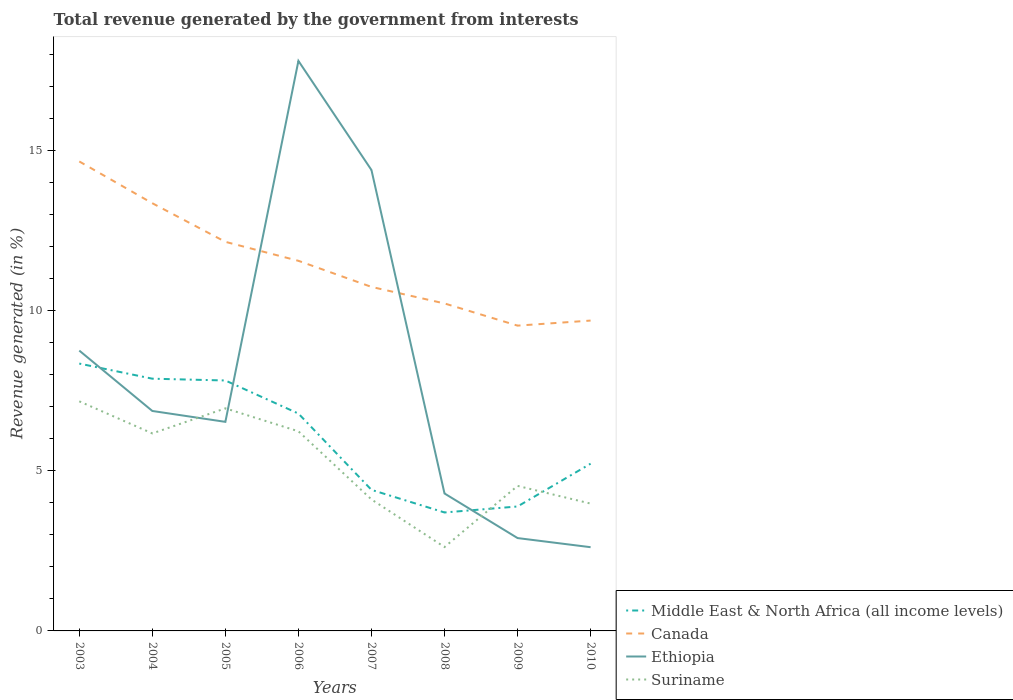Does the line corresponding to Suriname intersect with the line corresponding to Ethiopia?
Offer a terse response. Yes. Is the number of lines equal to the number of legend labels?
Keep it short and to the point. Yes. Across all years, what is the maximum total revenue generated in Canada?
Make the answer very short. 9.53. What is the total total revenue generated in Ethiopia in the graph?
Keep it short and to the point. 2.58. What is the difference between the highest and the second highest total revenue generated in Canada?
Your response must be concise. 5.12. Is the total revenue generated in Canada strictly greater than the total revenue generated in Middle East & North Africa (all income levels) over the years?
Your answer should be very brief. No. Does the graph contain any zero values?
Provide a short and direct response. No. Does the graph contain grids?
Your response must be concise. No. How are the legend labels stacked?
Your answer should be very brief. Vertical. What is the title of the graph?
Your response must be concise. Total revenue generated by the government from interests. Does "High income" appear as one of the legend labels in the graph?
Provide a short and direct response. No. What is the label or title of the Y-axis?
Your answer should be compact. Revenue generated (in %). What is the Revenue generated (in %) in Middle East & North Africa (all income levels) in 2003?
Your response must be concise. 8.34. What is the Revenue generated (in %) in Canada in 2003?
Your response must be concise. 14.65. What is the Revenue generated (in %) of Ethiopia in 2003?
Make the answer very short. 8.75. What is the Revenue generated (in %) of Suriname in 2003?
Offer a very short reply. 7.17. What is the Revenue generated (in %) in Middle East & North Africa (all income levels) in 2004?
Ensure brevity in your answer.  7.87. What is the Revenue generated (in %) of Canada in 2004?
Offer a very short reply. 13.35. What is the Revenue generated (in %) in Ethiopia in 2004?
Offer a very short reply. 6.86. What is the Revenue generated (in %) of Suriname in 2004?
Give a very brief answer. 6.16. What is the Revenue generated (in %) in Middle East & North Africa (all income levels) in 2005?
Your answer should be compact. 7.82. What is the Revenue generated (in %) in Canada in 2005?
Offer a terse response. 12.14. What is the Revenue generated (in %) of Ethiopia in 2005?
Your answer should be compact. 6.52. What is the Revenue generated (in %) in Suriname in 2005?
Provide a succinct answer. 6.95. What is the Revenue generated (in %) of Middle East & North Africa (all income levels) in 2006?
Provide a succinct answer. 6.78. What is the Revenue generated (in %) in Canada in 2006?
Give a very brief answer. 11.55. What is the Revenue generated (in %) in Ethiopia in 2006?
Offer a terse response. 17.79. What is the Revenue generated (in %) of Suriname in 2006?
Provide a succinct answer. 6.23. What is the Revenue generated (in %) in Middle East & North Africa (all income levels) in 2007?
Provide a short and direct response. 4.4. What is the Revenue generated (in %) of Canada in 2007?
Give a very brief answer. 10.74. What is the Revenue generated (in %) of Ethiopia in 2007?
Provide a succinct answer. 14.38. What is the Revenue generated (in %) in Suriname in 2007?
Provide a succinct answer. 4.1. What is the Revenue generated (in %) of Middle East & North Africa (all income levels) in 2008?
Your answer should be compact. 3.7. What is the Revenue generated (in %) of Canada in 2008?
Your answer should be compact. 10.22. What is the Revenue generated (in %) of Ethiopia in 2008?
Ensure brevity in your answer.  4.29. What is the Revenue generated (in %) of Suriname in 2008?
Ensure brevity in your answer.  2.62. What is the Revenue generated (in %) in Middle East & North Africa (all income levels) in 2009?
Provide a short and direct response. 3.88. What is the Revenue generated (in %) in Canada in 2009?
Your answer should be very brief. 9.53. What is the Revenue generated (in %) in Ethiopia in 2009?
Give a very brief answer. 2.9. What is the Revenue generated (in %) in Suriname in 2009?
Your answer should be very brief. 4.53. What is the Revenue generated (in %) of Middle East & North Africa (all income levels) in 2010?
Your response must be concise. 5.22. What is the Revenue generated (in %) of Canada in 2010?
Make the answer very short. 9.69. What is the Revenue generated (in %) in Ethiopia in 2010?
Ensure brevity in your answer.  2.61. What is the Revenue generated (in %) of Suriname in 2010?
Offer a very short reply. 3.97. Across all years, what is the maximum Revenue generated (in %) in Middle East & North Africa (all income levels)?
Ensure brevity in your answer.  8.34. Across all years, what is the maximum Revenue generated (in %) of Canada?
Ensure brevity in your answer.  14.65. Across all years, what is the maximum Revenue generated (in %) in Ethiopia?
Your answer should be compact. 17.79. Across all years, what is the maximum Revenue generated (in %) of Suriname?
Ensure brevity in your answer.  7.17. Across all years, what is the minimum Revenue generated (in %) in Middle East & North Africa (all income levels)?
Ensure brevity in your answer.  3.7. Across all years, what is the minimum Revenue generated (in %) of Canada?
Your answer should be compact. 9.53. Across all years, what is the minimum Revenue generated (in %) in Ethiopia?
Your response must be concise. 2.61. Across all years, what is the minimum Revenue generated (in %) of Suriname?
Keep it short and to the point. 2.62. What is the total Revenue generated (in %) of Middle East & North Africa (all income levels) in the graph?
Offer a terse response. 48.02. What is the total Revenue generated (in %) of Canada in the graph?
Offer a terse response. 91.87. What is the total Revenue generated (in %) in Ethiopia in the graph?
Keep it short and to the point. 64.11. What is the total Revenue generated (in %) of Suriname in the graph?
Keep it short and to the point. 41.73. What is the difference between the Revenue generated (in %) in Middle East & North Africa (all income levels) in 2003 and that in 2004?
Make the answer very short. 0.47. What is the difference between the Revenue generated (in %) in Canada in 2003 and that in 2004?
Provide a short and direct response. 1.3. What is the difference between the Revenue generated (in %) in Ethiopia in 2003 and that in 2004?
Keep it short and to the point. 1.88. What is the difference between the Revenue generated (in %) of Suriname in 2003 and that in 2004?
Offer a terse response. 1. What is the difference between the Revenue generated (in %) of Middle East & North Africa (all income levels) in 2003 and that in 2005?
Offer a very short reply. 0.53. What is the difference between the Revenue generated (in %) of Canada in 2003 and that in 2005?
Keep it short and to the point. 2.51. What is the difference between the Revenue generated (in %) of Ethiopia in 2003 and that in 2005?
Provide a succinct answer. 2.22. What is the difference between the Revenue generated (in %) of Suriname in 2003 and that in 2005?
Your answer should be very brief. 0.22. What is the difference between the Revenue generated (in %) in Middle East & North Africa (all income levels) in 2003 and that in 2006?
Offer a very short reply. 1.56. What is the difference between the Revenue generated (in %) in Canada in 2003 and that in 2006?
Your response must be concise. 3.1. What is the difference between the Revenue generated (in %) of Ethiopia in 2003 and that in 2006?
Ensure brevity in your answer.  -9.04. What is the difference between the Revenue generated (in %) of Suriname in 2003 and that in 2006?
Your answer should be very brief. 0.94. What is the difference between the Revenue generated (in %) in Middle East & North Africa (all income levels) in 2003 and that in 2007?
Keep it short and to the point. 3.94. What is the difference between the Revenue generated (in %) in Canada in 2003 and that in 2007?
Ensure brevity in your answer.  3.92. What is the difference between the Revenue generated (in %) of Ethiopia in 2003 and that in 2007?
Provide a succinct answer. -5.63. What is the difference between the Revenue generated (in %) of Suriname in 2003 and that in 2007?
Keep it short and to the point. 3.06. What is the difference between the Revenue generated (in %) of Middle East & North Africa (all income levels) in 2003 and that in 2008?
Your answer should be very brief. 4.65. What is the difference between the Revenue generated (in %) in Canada in 2003 and that in 2008?
Provide a succinct answer. 4.43. What is the difference between the Revenue generated (in %) in Ethiopia in 2003 and that in 2008?
Your response must be concise. 4.46. What is the difference between the Revenue generated (in %) in Suriname in 2003 and that in 2008?
Your answer should be compact. 4.55. What is the difference between the Revenue generated (in %) in Middle East & North Africa (all income levels) in 2003 and that in 2009?
Offer a terse response. 4.46. What is the difference between the Revenue generated (in %) in Canada in 2003 and that in 2009?
Offer a terse response. 5.12. What is the difference between the Revenue generated (in %) in Ethiopia in 2003 and that in 2009?
Offer a terse response. 5.85. What is the difference between the Revenue generated (in %) of Suriname in 2003 and that in 2009?
Offer a terse response. 2.64. What is the difference between the Revenue generated (in %) in Middle East & North Africa (all income levels) in 2003 and that in 2010?
Ensure brevity in your answer.  3.12. What is the difference between the Revenue generated (in %) of Canada in 2003 and that in 2010?
Make the answer very short. 4.97. What is the difference between the Revenue generated (in %) in Ethiopia in 2003 and that in 2010?
Your answer should be compact. 6.14. What is the difference between the Revenue generated (in %) in Suriname in 2003 and that in 2010?
Give a very brief answer. 3.19. What is the difference between the Revenue generated (in %) in Middle East & North Africa (all income levels) in 2004 and that in 2005?
Offer a terse response. 0.06. What is the difference between the Revenue generated (in %) in Canada in 2004 and that in 2005?
Your response must be concise. 1.21. What is the difference between the Revenue generated (in %) of Ethiopia in 2004 and that in 2005?
Keep it short and to the point. 0.34. What is the difference between the Revenue generated (in %) of Suriname in 2004 and that in 2005?
Your answer should be very brief. -0.78. What is the difference between the Revenue generated (in %) of Middle East & North Africa (all income levels) in 2004 and that in 2006?
Your answer should be very brief. 1.09. What is the difference between the Revenue generated (in %) of Canada in 2004 and that in 2006?
Ensure brevity in your answer.  1.8. What is the difference between the Revenue generated (in %) of Ethiopia in 2004 and that in 2006?
Provide a succinct answer. -10.93. What is the difference between the Revenue generated (in %) in Suriname in 2004 and that in 2006?
Provide a succinct answer. -0.07. What is the difference between the Revenue generated (in %) of Middle East & North Africa (all income levels) in 2004 and that in 2007?
Provide a short and direct response. 3.47. What is the difference between the Revenue generated (in %) in Canada in 2004 and that in 2007?
Keep it short and to the point. 2.61. What is the difference between the Revenue generated (in %) of Ethiopia in 2004 and that in 2007?
Keep it short and to the point. -7.52. What is the difference between the Revenue generated (in %) in Suriname in 2004 and that in 2007?
Provide a succinct answer. 2.06. What is the difference between the Revenue generated (in %) in Middle East & North Africa (all income levels) in 2004 and that in 2008?
Ensure brevity in your answer.  4.18. What is the difference between the Revenue generated (in %) in Canada in 2004 and that in 2008?
Make the answer very short. 3.13. What is the difference between the Revenue generated (in %) of Ethiopia in 2004 and that in 2008?
Your answer should be very brief. 2.58. What is the difference between the Revenue generated (in %) of Suriname in 2004 and that in 2008?
Offer a very short reply. 3.55. What is the difference between the Revenue generated (in %) in Middle East & North Africa (all income levels) in 2004 and that in 2009?
Provide a short and direct response. 3.99. What is the difference between the Revenue generated (in %) in Canada in 2004 and that in 2009?
Keep it short and to the point. 3.82. What is the difference between the Revenue generated (in %) in Ethiopia in 2004 and that in 2009?
Give a very brief answer. 3.97. What is the difference between the Revenue generated (in %) in Suriname in 2004 and that in 2009?
Provide a short and direct response. 1.64. What is the difference between the Revenue generated (in %) in Middle East & North Africa (all income levels) in 2004 and that in 2010?
Ensure brevity in your answer.  2.65. What is the difference between the Revenue generated (in %) of Canada in 2004 and that in 2010?
Make the answer very short. 3.66. What is the difference between the Revenue generated (in %) of Ethiopia in 2004 and that in 2010?
Make the answer very short. 4.25. What is the difference between the Revenue generated (in %) of Suriname in 2004 and that in 2010?
Your response must be concise. 2.19. What is the difference between the Revenue generated (in %) in Middle East & North Africa (all income levels) in 2005 and that in 2006?
Your response must be concise. 1.03. What is the difference between the Revenue generated (in %) in Canada in 2005 and that in 2006?
Provide a short and direct response. 0.59. What is the difference between the Revenue generated (in %) in Ethiopia in 2005 and that in 2006?
Make the answer very short. -11.27. What is the difference between the Revenue generated (in %) of Suriname in 2005 and that in 2006?
Give a very brief answer. 0.72. What is the difference between the Revenue generated (in %) in Middle East & North Africa (all income levels) in 2005 and that in 2007?
Provide a short and direct response. 3.41. What is the difference between the Revenue generated (in %) of Canada in 2005 and that in 2007?
Provide a short and direct response. 1.41. What is the difference between the Revenue generated (in %) of Ethiopia in 2005 and that in 2007?
Your response must be concise. -7.86. What is the difference between the Revenue generated (in %) of Suriname in 2005 and that in 2007?
Your answer should be compact. 2.84. What is the difference between the Revenue generated (in %) in Middle East & North Africa (all income levels) in 2005 and that in 2008?
Your answer should be very brief. 4.12. What is the difference between the Revenue generated (in %) in Canada in 2005 and that in 2008?
Offer a very short reply. 1.92. What is the difference between the Revenue generated (in %) in Ethiopia in 2005 and that in 2008?
Ensure brevity in your answer.  2.24. What is the difference between the Revenue generated (in %) of Suriname in 2005 and that in 2008?
Keep it short and to the point. 4.33. What is the difference between the Revenue generated (in %) in Middle East & North Africa (all income levels) in 2005 and that in 2009?
Your answer should be compact. 3.93. What is the difference between the Revenue generated (in %) of Canada in 2005 and that in 2009?
Your answer should be very brief. 2.62. What is the difference between the Revenue generated (in %) in Ethiopia in 2005 and that in 2009?
Offer a terse response. 3.63. What is the difference between the Revenue generated (in %) in Suriname in 2005 and that in 2009?
Your answer should be compact. 2.42. What is the difference between the Revenue generated (in %) of Middle East & North Africa (all income levels) in 2005 and that in 2010?
Your answer should be very brief. 2.6. What is the difference between the Revenue generated (in %) of Canada in 2005 and that in 2010?
Offer a terse response. 2.46. What is the difference between the Revenue generated (in %) in Ethiopia in 2005 and that in 2010?
Offer a terse response. 3.91. What is the difference between the Revenue generated (in %) in Suriname in 2005 and that in 2010?
Make the answer very short. 2.97. What is the difference between the Revenue generated (in %) of Middle East & North Africa (all income levels) in 2006 and that in 2007?
Make the answer very short. 2.38. What is the difference between the Revenue generated (in %) in Canada in 2006 and that in 2007?
Offer a terse response. 0.81. What is the difference between the Revenue generated (in %) of Ethiopia in 2006 and that in 2007?
Ensure brevity in your answer.  3.41. What is the difference between the Revenue generated (in %) of Suriname in 2006 and that in 2007?
Offer a very short reply. 2.13. What is the difference between the Revenue generated (in %) of Middle East & North Africa (all income levels) in 2006 and that in 2008?
Your response must be concise. 3.09. What is the difference between the Revenue generated (in %) in Canada in 2006 and that in 2008?
Make the answer very short. 1.33. What is the difference between the Revenue generated (in %) in Ethiopia in 2006 and that in 2008?
Keep it short and to the point. 13.5. What is the difference between the Revenue generated (in %) of Suriname in 2006 and that in 2008?
Make the answer very short. 3.61. What is the difference between the Revenue generated (in %) of Middle East & North Africa (all income levels) in 2006 and that in 2009?
Provide a short and direct response. 2.9. What is the difference between the Revenue generated (in %) of Canada in 2006 and that in 2009?
Make the answer very short. 2.02. What is the difference between the Revenue generated (in %) of Ethiopia in 2006 and that in 2009?
Make the answer very short. 14.89. What is the difference between the Revenue generated (in %) of Suriname in 2006 and that in 2009?
Make the answer very short. 1.7. What is the difference between the Revenue generated (in %) of Middle East & North Africa (all income levels) in 2006 and that in 2010?
Provide a succinct answer. 1.56. What is the difference between the Revenue generated (in %) of Canada in 2006 and that in 2010?
Offer a terse response. 1.87. What is the difference between the Revenue generated (in %) of Ethiopia in 2006 and that in 2010?
Give a very brief answer. 15.18. What is the difference between the Revenue generated (in %) of Suriname in 2006 and that in 2010?
Your response must be concise. 2.26. What is the difference between the Revenue generated (in %) in Middle East & North Africa (all income levels) in 2007 and that in 2008?
Provide a short and direct response. 0.71. What is the difference between the Revenue generated (in %) of Canada in 2007 and that in 2008?
Keep it short and to the point. 0.52. What is the difference between the Revenue generated (in %) in Ethiopia in 2007 and that in 2008?
Offer a very short reply. 10.09. What is the difference between the Revenue generated (in %) of Suriname in 2007 and that in 2008?
Provide a succinct answer. 1.49. What is the difference between the Revenue generated (in %) in Middle East & North Africa (all income levels) in 2007 and that in 2009?
Keep it short and to the point. 0.52. What is the difference between the Revenue generated (in %) of Canada in 2007 and that in 2009?
Provide a short and direct response. 1.21. What is the difference between the Revenue generated (in %) of Ethiopia in 2007 and that in 2009?
Offer a very short reply. 11.49. What is the difference between the Revenue generated (in %) of Suriname in 2007 and that in 2009?
Your response must be concise. -0.42. What is the difference between the Revenue generated (in %) of Middle East & North Africa (all income levels) in 2007 and that in 2010?
Give a very brief answer. -0.82. What is the difference between the Revenue generated (in %) in Canada in 2007 and that in 2010?
Make the answer very short. 1.05. What is the difference between the Revenue generated (in %) of Ethiopia in 2007 and that in 2010?
Ensure brevity in your answer.  11.77. What is the difference between the Revenue generated (in %) of Suriname in 2007 and that in 2010?
Offer a very short reply. 0.13. What is the difference between the Revenue generated (in %) of Middle East & North Africa (all income levels) in 2008 and that in 2009?
Ensure brevity in your answer.  -0.19. What is the difference between the Revenue generated (in %) of Canada in 2008 and that in 2009?
Your answer should be compact. 0.69. What is the difference between the Revenue generated (in %) of Ethiopia in 2008 and that in 2009?
Your answer should be compact. 1.39. What is the difference between the Revenue generated (in %) of Suriname in 2008 and that in 2009?
Provide a short and direct response. -1.91. What is the difference between the Revenue generated (in %) in Middle East & North Africa (all income levels) in 2008 and that in 2010?
Keep it short and to the point. -1.52. What is the difference between the Revenue generated (in %) in Canada in 2008 and that in 2010?
Make the answer very short. 0.53. What is the difference between the Revenue generated (in %) of Ethiopia in 2008 and that in 2010?
Your answer should be very brief. 1.68. What is the difference between the Revenue generated (in %) in Suriname in 2008 and that in 2010?
Keep it short and to the point. -1.36. What is the difference between the Revenue generated (in %) of Middle East & North Africa (all income levels) in 2009 and that in 2010?
Provide a short and direct response. -1.34. What is the difference between the Revenue generated (in %) in Canada in 2009 and that in 2010?
Provide a short and direct response. -0.16. What is the difference between the Revenue generated (in %) in Ethiopia in 2009 and that in 2010?
Offer a terse response. 0.29. What is the difference between the Revenue generated (in %) in Suriname in 2009 and that in 2010?
Make the answer very short. 0.55. What is the difference between the Revenue generated (in %) in Middle East & North Africa (all income levels) in 2003 and the Revenue generated (in %) in Canada in 2004?
Provide a succinct answer. -5. What is the difference between the Revenue generated (in %) of Middle East & North Africa (all income levels) in 2003 and the Revenue generated (in %) of Ethiopia in 2004?
Ensure brevity in your answer.  1.48. What is the difference between the Revenue generated (in %) in Middle East & North Africa (all income levels) in 2003 and the Revenue generated (in %) in Suriname in 2004?
Make the answer very short. 2.18. What is the difference between the Revenue generated (in %) in Canada in 2003 and the Revenue generated (in %) in Ethiopia in 2004?
Your answer should be very brief. 7.79. What is the difference between the Revenue generated (in %) of Canada in 2003 and the Revenue generated (in %) of Suriname in 2004?
Provide a succinct answer. 8.49. What is the difference between the Revenue generated (in %) in Ethiopia in 2003 and the Revenue generated (in %) in Suriname in 2004?
Provide a succinct answer. 2.59. What is the difference between the Revenue generated (in %) of Middle East & North Africa (all income levels) in 2003 and the Revenue generated (in %) of Canada in 2005?
Ensure brevity in your answer.  -3.8. What is the difference between the Revenue generated (in %) in Middle East & North Africa (all income levels) in 2003 and the Revenue generated (in %) in Ethiopia in 2005?
Provide a succinct answer. 1.82. What is the difference between the Revenue generated (in %) in Middle East & North Africa (all income levels) in 2003 and the Revenue generated (in %) in Suriname in 2005?
Your response must be concise. 1.4. What is the difference between the Revenue generated (in %) in Canada in 2003 and the Revenue generated (in %) in Ethiopia in 2005?
Give a very brief answer. 8.13. What is the difference between the Revenue generated (in %) in Canada in 2003 and the Revenue generated (in %) in Suriname in 2005?
Ensure brevity in your answer.  7.71. What is the difference between the Revenue generated (in %) in Ethiopia in 2003 and the Revenue generated (in %) in Suriname in 2005?
Ensure brevity in your answer.  1.8. What is the difference between the Revenue generated (in %) in Middle East & North Africa (all income levels) in 2003 and the Revenue generated (in %) in Canada in 2006?
Offer a very short reply. -3.21. What is the difference between the Revenue generated (in %) in Middle East & North Africa (all income levels) in 2003 and the Revenue generated (in %) in Ethiopia in 2006?
Your answer should be very brief. -9.45. What is the difference between the Revenue generated (in %) of Middle East & North Africa (all income levels) in 2003 and the Revenue generated (in %) of Suriname in 2006?
Keep it short and to the point. 2.11. What is the difference between the Revenue generated (in %) in Canada in 2003 and the Revenue generated (in %) in Ethiopia in 2006?
Ensure brevity in your answer.  -3.14. What is the difference between the Revenue generated (in %) of Canada in 2003 and the Revenue generated (in %) of Suriname in 2006?
Give a very brief answer. 8.42. What is the difference between the Revenue generated (in %) in Ethiopia in 2003 and the Revenue generated (in %) in Suriname in 2006?
Give a very brief answer. 2.52. What is the difference between the Revenue generated (in %) in Middle East & North Africa (all income levels) in 2003 and the Revenue generated (in %) in Canada in 2007?
Keep it short and to the point. -2.39. What is the difference between the Revenue generated (in %) of Middle East & North Africa (all income levels) in 2003 and the Revenue generated (in %) of Ethiopia in 2007?
Make the answer very short. -6.04. What is the difference between the Revenue generated (in %) in Middle East & North Africa (all income levels) in 2003 and the Revenue generated (in %) in Suriname in 2007?
Give a very brief answer. 4.24. What is the difference between the Revenue generated (in %) in Canada in 2003 and the Revenue generated (in %) in Ethiopia in 2007?
Make the answer very short. 0.27. What is the difference between the Revenue generated (in %) of Canada in 2003 and the Revenue generated (in %) of Suriname in 2007?
Keep it short and to the point. 10.55. What is the difference between the Revenue generated (in %) of Ethiopia in 2003 and the Revenue generated (in %) of Suriname in 2007?
Make the answer very short. 4.65. What is the difference between the Revenue generated (in %) of Middle East & North Africa (all income levels) in 2003 and the Revenue generated (in %) of Canada in 2008?
Give a very brief answer. -1.88. What is the difference between the Revenue generated (in %) of Middle East & North Africa (all income levels) in 2003 and the Revenue generated (in %) of Ethiopia in 2008?
Keep it short and to the point. 4.05. What is the difference between the Revenue generated (in %) in Middle East & North Africa (all income levels) in 2003 and the Revenue generated (in %) in Suriname in 2008?
Offer a terse response. 5.73. What is the difference between the Revenue generated (in %) in Canada in 2003 and the Revenue generated (in %) in Ethiopia in 2008?
Ensure brevity in your answer.  10.36. What is the difference between the Revenue generated (in %) of Canada in 2003 and the Revenue generated (in %) of Suriname in 2008?
Offer a terse response. 12.03. What is the difference between the Revenue generated (in %) of Ethiopia in 2003 and the Revenue generated (in %) of Suriname in 2008?
Offer a terse response. 6.13. What is the difference between the Revenue generated (in %) in Middle East & North Africa (all income levels) in 2003 and the Revenue generated (in %) in Canada in 2009?
Ensure brevity in your answer.  -1.18. What is the difference between the Revenue generated (in %) of Middle East & North Africa (all income levels) in 2003 and the Revenue generated (in %) of Ethiopia in 2009?
Give a very brief answer. 5.45. What is the difference between the Revenue generated (in %) of Middle East & North Africa (all income levels) in 2003 and the Revenue generated (in %) of Suriname in 2009?
Keep it short and to the point. 3.82. What is the difference between the Revenue generated (in %) in Canada in 2003 and the Revenue generated (in %) in Ethiopia in 2009?
Your answer should be compact. 11.75. What is the difference between the Revenue generated (in %) of Canada in 2003 and the Revenue generated (in %) of Suriname in 2009?
Your answer should be compact. 10.13. What is the difference between the Revenue generated (in %) in Ethiopia in 2003 and the Revenue generated (in %) in Suriname in 2009?
Ensure brevity in your answer.  4.22. What is the difference between the Revenue generated (in %) in Middle East & North Africa (all income levels) in 2003 and the Revenue generated (in %) in Canada in 2010?
Your response must be concise. -1.34. What is the difference between the Revenue generated (in %) of Middle East & North Africa (all income levels) in 2003 and the Revenue generated (in %) of Ethiopia in 2010?
Provide a short and direct response. 5.73. What is the difference between the Revenue generated (in %) of Middle East & North Africa (all income levels) in 2003 and the Revenue generated (in %) of Suriname in 2010?
Give a very brief answer. 4.37. What is the difference between the Revenue generated (in %) of Canada in 2003 and the Revenue generated (in %) of Ethiopia in 2010?
Offer a very short reply. 12.04. What is the difference between the Revenue generated (in %) in Canada in 2003 and the Revenue generated (in %) in Suriname in 2010?
Give a very brief answer. 10.68. What is the difference between the Revenue generated (in %) in Ethiopia in 2003 and the Revenue generated (in %) in Suriname in 2010?
Offer a very short reply. 4.78. What is the difference between the Revenue generated (in %) in Middle East & North Africa (all income levels) in 2004 and the Revenue generated (in %) in Canada in 2005?
Your answer should be compact. -4.27. What is the difference between the Revenue generated (in %) in Middle East & North Africa (all income levels) in 2004 and the Revenue generated (in %) in Ethiopia in 2005?
Make the answer very short. 1.35. What is the difference between the Revenue generated (in %) in Middle East & North Africa (all income levels) in 2004 and the Revenue generated (in %) in Suriname in 2005?
Offer a terse response. 0.93. What is the difference between the Revenue generated (in %) in Canada in 2004 and the Revenue generated (in %) in Ethiopia in 2005?
Offer a very short reply. 6.82. What is the difference between the Revenue generated (in %) of Canada in 2004 and the Revenue generated (in %) of Suriname in 2005?
Give a very brief answer. 6.4. What is the difference between the Revenue generated (in %) in Ethiopia in 2004 and the Revenue generated (in %) in Suriname in 2005?
Your answer should be compact. -0.08. What is the difference between the Revenue generated (in %) in Middle East & North Africa (all income levels) in 2004 and the Revenue generated (in %) in Canada in 2006?
Your response must be concise. -3.68. What is the difference between the Revenue generated (in %) in Middle East & North Africa (all income levels) in 2004 and the Revenue generated (in %) in Ethiopia in 2006?
Ensure brevity in your answer.  -9.92. What is the difference between the Revenue generated (in %) in Middle East & North Africa (all income levels) in 2004 and the Revenue generated (in %) in Suriname in 2006?
Ensure brevity in your answer.  1.64. What is the difference between the Revenue generated (in %) in Canada in 2004 and the Revenue generated (in %) in Ethiopia in 2006?
Ensure brevity in your answer.  -4.44. What is the difference between the Revenue generated (in %) in Canada in 2004 and the Revenue generated (in %) in Suriname in 2006?
Offer a terse response. 7.12. What is the difference between the Revenue generated (in %) in Ethiopia in 2004 and the Revenue generated (in %) in Suriname in 2006?
Ensure brevity in your answer.  0.63. What is the difference between the Revenue generated (in %) of Middle East & North Africa (all income levels) in 2004 and the Revenue generated (in %) of Canada in 2007?
Provide a succinct answer. -2.86. What is the difference between the Revenue generated (in %) in Middle East & North Africa (all income levels) in 2004 and the Revenue generated (in %) in Ethiopia in 2007?
Provide a short and direct response. -6.51. What is the difference between the Revenue generated (in %) of Middle East & North Africa (all income levels) in 2004 and the Revenue generated (in %) of Suriname in 2007?
Give a very brief answer. 3.77. What is the difference between the Revenue generated (in %) in Canada in 2004 and the Revenue generated (in %) in Ethiopia in 2007?
Offer a terse response. -1.04. What is the difference between the Revenue generated (in %) in Canada in 2004 and the Revenue generated (in %) in Suriname in 2007?
Keep it short and to the point. 9.24. What is the difference between the Revenue generated (in %) of Ethiopia in 2004 and the Revenue generated (in %) of Suriname in 2007?
Give a very brief answer. 2.76. What is the difference between the Revenue generated (in %) in Middle East & North Africa (all income levels) in 2004 and the Revenue generated (in %) in Canada in 2008?
Offer a terse response. -2.35. What is the difference between the Revenue generated (in %) in Middle East & North Africa (all income levels) in 2004 and the Revenue generated (in %) in Ethiopia in 2008?
Keep it short and to the point. 3.58. What is the difference between the Revenue generated (in %) of Middle East & North Africa (all income levels) in 2004 and the Revenue generated (in %) of Suriname in 2008?
Offer a terse response. 5.25. What is the difference between the Revenue generated (in %) in Canada in 2004 and the Revenue generated (in %) in Ethiopia in 2008?
Provide a short and direct response. 9.06. What is the difference between the Revenue generated (in %) in Canada in 2004 and the Revenue generated (in %) in Suriname in 2008?
Your answer should be compact. 10.73. What is the difference between the Revenue generated (in %) in Ethiopia in 2004 and the Revenue generated (in %) in Suriname in 2008?
Give a very brief answer. 4.25. What is the difference between the Revenue generated (in %) in Middle East & North Africa (all income levels) in 2004 and the Revenue generated (in %) in Canada in 2009?
Provide a short and direct response. -1.66. What is the difference between the Revenue generated (in %) of Middle East & North Africa (all income levels) in 2004 and the Revenue generated (in %) of Ethiopia in 2009?
Ensure brevity in your answer.  4.97. What is the difference between the Revenue generated (in %) in Middle East & North Africa (all income levels) in 2004 and the Revenue generated (in %) in Suriname in 2009?
Your answer should be very brief. 3.35. What is the difference between the Revenue generated (in %) in Canada in 2004 and the Revenue generated (in %) in Ethiopia in 2009?
Offer a terse response. 10.45. What is the difference between the Revenue generated (in %) of Canada in 2004 and the Revenue generated (in %) of Suriname in 2009?
Provide a short and direct response. 8.82. What is the difference between the Revenue generated (in %) in Ethiopia in 2004 and the Revenue generated (in %) in Suriname in 2009?
Your response must be concise. 2.34. What is the difference between the Revenue generated (in %) of Middle East & North Africa (all income levels) in 2004 and the Revenue generated (in %) of Canada in 2010?
Your answer should be compact. -1.81. What is the difference between the Revenue generated (in %) of Middle East & North Africa (all income levels) in 2004 and the Revenue generated (in %) of Ethiopia in 2010?
Offer a very short reply. 5.26. What is the difference between the Revenue generated (in %) in Middle East & North Africa (all income levels) in 2004 and the Revenue generated (in %) in Suriname in 2010?
Make the answer very short. 3.9. What is the difference between the Revenue generated (in %) in Canada in 2004 and the Revenue generated (in %) in Ethiopia in 2010?
Your answer should be compact. 10.74. What is the difference between the Revenue generated (in %) of Canada in 2004 and the Revenue generated (in %) of Suriname in 2010?
Offer a very short reply. 9.37. What is the difference between the Revenue generated (in %) of Ethiopia in 2004 and the Revenue generated (in %) of Suriname in 2010?
Your answer should be compact. 2.89. What is the difference between the Revenue generated (in %) in Middle East & North Africa (all income levels) in 2005 and the Revenue generated (in %) in Canada in 2006?
Provide a short and direct response. -3.74. What is the difference between the Revenue generated (in %) in Middle East & North Africa (all income levels) in 2005 and the Revenue generated (in %) in Ethiopia in 2006?
Provide a short and direct response. -9.97. What is the difference between the Revenue generated (in %) in Middle East & North Africa (all income levels) in 2005 and the Revenue generated (in %) in Suriname in 2006?
Offer a terse response. 1.59. What is the difference between the Revenue generated (in %) in Canada in 2005 and the Revenue generated (in %) in Ethiopia in 2006?
Ensure brevity in your answer.  -5.65. What is the difference between the Revenue generated (in %) in Canada in 2005 and the Revenue generated (in %) in Suriname in 2006?
Keep it short and to the point. 5.91. What is the difference between the Revenue generated (in %) in Ethiopia in 2005 and the Revenue generated (in %) in Suriname in 2006?
Provide a succinct answer. 0.29. What is the difference between the Revenue generated (in %) of Middle East & North Africa (all income levels) in 2005 and the Revenue generated (in %) of Canada in 2007?
Offer a terse response. -2.92. What is the difference between the Revenue generated (in %) of Middle East & North Africa (all income levels) in 2005 and the Revenue generated (in %) of Ethiopia in 2007?
Give a very brief answer. -6.57. What is the difference between the Revenue generated (in %) in Middle East & North Africa (all income levels) in 2005 and the Revenue generated (in %) in Suriname in 2007?
Keep it short and to the point. 3.71. What is the difference between the Revenue generated (in %) of Canada in 2005 and the Revenue generated (in %) of Ethiopia in 2007?
Your answer should be compact. -2.24. What is the difference between the Revenue generated (in %) in Canada in 2005 and the Revenue generated (in %) in Suriname in 2007?
Ensure brevity in your answer.  8.04. What is the difference between the Revenue generated (in %) of Ethiopia in 2005 and the Revenue generated (in %) of Suriname in 2007?
Give a very brief answer. 2.42. What is the difference between the Revenue generated (in %) of Middle East & North Africa (all income levels) in 2005 and the Revenue generated (in %) of Canada in 2008?
Provide a short and direct response. -2.4. What is the difference between the Revenue generated (in %) of Middle East & North Africa (all income levels) in 2005 and the Revenue generated (in %) of Ethiopia in 2008?
Your answer should be very brief. 3.53. What is the difference between the Revenue generated (in %) in Middle East & North Africa (all income levels) in 2005 and the Revenue generated (in %) in Suriname in 2008?
Keep it short and to the point. 5.2. What is the difference between the Revenue generated (in %) of Canada in 2005 and the Revenue generated (in %) of Ethiopia in 2008?
Provide a short and direct response. 7.85. What is the difference between the Revenue generated (in %) in Canada in 2005 and the Revenue generated (in %) in Suriname in 2008?
Your answer should be compact. 9.53. What is the difference between the Revenue generated (in %) in Ethiopia in 2005 and the Revenue generated (in %) in Suriname in 2008?
Offer a very short reply. 3.91. What is the difference between the Revenue generated (in %) in Middle East & North Africa (all income levels) in 2005 and the Revenue generated (in %) in Canada in 2009?
Provide a short and direct response. -1.71. What is the difference between the Revenue generated (in %) of Middle East & North Africa (all income levels) in 2005 and the Revenue generated (in %) of Ethiopia in 2009?
Your answer should be very brief. 4.92. What is the difference between the Revenue generated (in %) of Middle East & North Africa (all income levels) in 2005 and the Revenue generated (in %) of Suriname in 2009?
Ensure brevity in your answer.  3.29. What is the difference between the Revenue generated (in %) of Canada in 2005 and the Revenue generated (in %) of Ethiopia in 2009?
Offer a terse response. 9.25. What is the difference between the Revenue generated (in %) of Canada in 2005 and the Revenue generated (in %) of Suriname in 2009?
Your answer should be compact. 7.62. What is the difference between the Revenue generated (in %) in Ethiopia in 2005 and the Revenue generated (in %) in Suriname in 2009?
Offer a very short reply. 2. What is the difference between the Revenue generated (in %) of Middle East & North Africa (all income levels) in 2005 and the Revenue generated (in %) of Canada in 2010?
Your response must be concise. -1.87. What is the difference between the Revenue generated (in %) of Middle East & North Africa (all income levels) in 2005 and the Revenue generated (in %) of Ethiopia in 2010?
Give a very brief answer. 5.2. What is the difference between the Revenue generated (in %) in Middle East & North Africa (all income levels) in 2005 and the Revenue generated (in %) in Suriname in 2010?
Provide a succinct answer. 3.84. What is the difference between the Revenue generated (in %) in Canada in 2005 and the Revenue generated (in %) in Ethiopia in 2010?
Provide a succinct answer. 9.53. What is the difference between the Revenue generated (in %) of Canada in 2005 and the Revenue generated (in %) of Suriname in 2010?
Your answer should be compact. 8.17. What is the difference between the Revenue generated (in %) in Ethiopia in 2005 and the Revenue generated (in %) in Suriname in 2010?
Make the answer very short. 2.55. What is the difference between the Revenue generated (in %) in Middle East & North Africa (all income levels) in 2006 and the Revenue generated (in %) in Canada in 2007?
Provide a short and direct response. -3.95. What is the difference between the Revenue generated (in %) in Middle East & North Africa (all income levels) in 2006 and the Revenue generated (in %) in Ethiopia in 2007?
Your response must be concise. -7.6. What is the difference between the Revenue generated (in %) in Middle East & North Africa (all income levels) in 2006 and the Revenue generated (in %) in Suriname in 2007?
Your answer should be compact. 2.68. What is the difference between the Revenue generated (in %) of Canada in 2006 and the Revenue generated (in %) of Ethiopia in 2007?
Ensure brevity in your answer.  -2.83. What is the difference between the Revenue generated (in %) of Canada in 2006 and the Revenue generated (in %) of Suriname in 2007?
Provide a short and direct response. 7.45. What is the difference between the Revenue generated (in %) in Ethiopia in 2006 and the Revenue generated (in %) in Suriname in 2007?
Your answer should be compact. 13.69. What is the difference between the Revenue generated (in %) in Middle East & North Africa (all income levels) in 2006 and the Revenue generated (in %) in Canada in 2008?
Your response must be concise. -3.44. What is the difference between the Revenue generated (in %) of Middle East & North Africa (all income levels) in 2006 and the Revenue generated (in %) of Ethiopia in 2008?
Your answer should be very brief. 2.49. What is the difference between the Revenue generated (in %) of Middle East & North Africa (all income levels) in 2006 and the Revenue generated (in %) of Suriname in 2008?
Keep it short and to the point. 4.17. What is the difference between the Revenue generated (in %) in Canada in 2006 and the Revenue generated (in %) in Ethiopia in 2008?
Your answer should be compact. 7.26. What is the difference between the Revenue generated (in %) in Canada in 2006 and the Revenue generated (in %) in Suriname in 2008?
Your answer should be very brief. 8.93. What is the difference between the Revenue generated (in %) in Ethiopia in 2006 and the Revenue generated (in %) in Suriname in 2008?
Offer a terse response. 15.17. What is the difference between the Revenue generated (in %) in Middle East & North Africa (all income levels) in 2006 and the Revenue generated (in %) in Canada in 2009?
Provide a succinct answer. -2.74. What is the difference between the Revenue generated (in %) in Middle East & North Africa (all income levels) in 2006 and the Revenue generated (in %) in Ethiopia in 2009?
Your answer should be very brief. 3.89. What is the difference between the Revenue generated (in %) in Middle East & North Africa (all income levels) in 2006 and the Revenue generated (in %) in Suriname in 2009?
Ensure brevity in your answer.  2.26. What is the difference between the Revenue generated (in %) of Canada in 2006 and the Revenue generated (in %) of Ethiopia in 2009?
Offer a very short reply. 8.65. What is the difference between the Revenue generated (in %) in Canada in 2006 and the Revenue generated (in %) in Suriname in 2009?
Offer a terse response. 7.02. What is the difference between the Revenue generated (in %) in Ethiopia in 2006 and the Revenue generated (in %) in Suriname in 2009?
Your answer should be very brief. 13.26. What is the difference between the Revenue generated (in %) in Middle East & North Africa (all income levels) in 2006 and the Revenue generated (in %) in Canada in 2010?
Ensure brevity in your answer.  -2.9. What is the difference between the Revenue generated (in %) in Middle East & North Africa (all income levels) in 2006 and the Revenue generated (in %) in Ethiopia in 2010?
Provide a short and direct response. 4.17. What is the difference between the Revenue generated (in %) of Middle East & North Africa (all income levels) in 2006 and the Revenue generated (in %) of Suriname in 2010?
Provide a succinct answer. 2.81. What is the difference between the Revenue generated (in %) in Canada in 2006 and the Revenue generated (in %) in Ethiopia in 2010?
Provide a short and direct response. 8.94. What is the difference between the Revenue generated (in %) in Canada in 2006 and the Revenue generated (in %) in Suriname in 2010?
Offer a very short reply. 7.58. What is the difference between the Revenue generated (in %) in Ethiopia in 2006 and the Revenue generated (in %) in Suriname in 2010?
Ensure brevity in your answer.  13.82. What is the difference between the Revenue generated (in %) of Middle East & North Africa (all income levels) in 2007 and the Revenue generated (in %) of Canada in 2008?
Keep it short and to the point. -5.82. What is the difference between the Revenue generated (in %) in Middle East & North Africa (all income levels) in 2007 and the Revenue generated (in %) in Ethiopia in 2008?
Ensure brevity in your answer.  0.11. What is the difference between the Revenue generated (in %) of Middle East & North Africa (all income levels) in 2007 and the Revenue generated (in %) of Suriname in 2008?
Keep it short and to the point. 1.78. What is the difference between the Revenue generated (in %) in Canada in 2007 and the Revenue generated (in %) in Ethiopia in 2008?
Offer a very short reply. 6.45. What is the difference between the Revenue generated (in %) of Canada in 2007 and the Revenue generated (in %) of Suriname in 2008?
Provide a short and direct response. 8.12. What is the difference between the Revenue generated (in %) in Ethiopia in 2007 and the Revenue generated (in %) in Suriname in 2008?
Give a very brief answer. 11.77. What is the difference between the Revenue generated (in %) in Middle East & North Africa (all income levels) in 2007 and the Revenue generated (in %) in Canada in 2009?
Offer a very short reply. -5.13. What is the difference between the Revenue generated (in %) of Middle East & North Africa (all income levels) in 2007 and the Revenue generated (in %) of Ethiopia in 2009?
Give a very brief answer. 1.5. What is the difference between the Revenue generated (in %) of Middle East & North Africa (all income levels) in 2007 and the Revenue generated (in %) of Suriname in 2009?
Your response must be concise. -0.12. What is the difference between the Revenue generated (in %) in Canada in 2007 and the Revenue generated (in %) in Ethiopia in 2009?
Make the answer very short. 7.84. What is the difference between the Revenue generated (in %) in Canada in 2007 and the Revenue generated (in %) in Suriname in 2009?
Your answer should be very brief. 6.21. What is the difference between the Revenue generated (in %) in Ethiopia in 2007 and the Revenue generated (in %) in Suriname in 2009?
Provide a short and direct response. 9.86. What is the difference between the Revenue generated (in %) in Middle East & North Africa (all income levels) in 2007 and the Revenue generated (in %) in Canada in 2010?
Your answer should be very brief. -5.28. What is the difference between the Revenue generated (in %) of Middle East & North Africa (all income levels) in 2007 and the Revenue generated (in %) of Ethiopia in 2010?
Provide a succinct answer. 1.79. What is the difference between the Revenue generated (in %) of Middle East & North Africa (all income levels) in 2007 and the Revenue generated (in %) of Suriname in 2010?
Make the answer very short. 0.43. What is the difference between the Revenue generated (in %) in Canada in 2007 and the Revenue generated (in %) in Ethiopia in 2010?
Offer a very short reply. 8.12. What is the difference between the Revenue generated (in %) in Canada in 2007 and the Revenue generated (in %) in Suriname in 2010?
Offer a terse response. 6.76. What is the difference between the Revenue generated (in %) of Ethiopia in 2007 and the Revenue generated (in %) of Suriname in 2010?
Keep it short and to the point. 10.41. What is the difference between the Revenue generated (in %) of Middle East & North Africa (all income levels) in 2008 and the Revenue generated (in %) of Canada in 2009?
Keep it short and to the point. -5.83. What is the difference between the Revenue generated (in %) in Middle East & North Africa (all income levels) in 2008 and the Revenue generated (in %) in Ethiopia in 2009?
Keep it short and to the point. 0.8. What is the difference between the Revenue generated (in %) of Middle East & North Africa (all income levels) in 2008 and the Revenue generated (in %) of Suriname in 2009?
Make the answer very short. -0.83. What is the difference between the Revenue generated (in %) in Canada in 2008 and the Revenue generated (in %) in Ethiopia in 2009?
Your response must be concise. 7.32. What is the difference between the Revenue generated (in %) of Canada in 2008 and the Revenue generated (in %) of Suriname in 2009?
Provide a succinct answer. 5.69. What is the difference between the Revenue generated (in %) of Ethiopia in 2008 and the Revenue generated (in %) of Suriname in 2009?
Keep it short and to the point. -0.24. What is the difference between the Revenue generated (in %) of Middle East & North Africa (all income levels) in 2008 and the Revenue generated (in %) of Canada in 2010?
Your response must be concise. -5.99. What is the difference between the Revenue generated (in %) of Middle East & North Africa (all income levels) in 2008 and the Revenue generated (in %) of Ethiopia in 2010?
Give a very brief answer. 1.08. What is the difference between the Revenue generated (in %) of Middle East & North Africa (all income levels) in 2008 and the Revenue generated (in %) of Suriname in 2010?
Provide a short and direct response. -0.28. What is the difference between the Revenue generated (in %) of Canada in 2008 and the Revenue generated (in %) of Ethiopia in 2010?
Offer a very short reply. 7.61. What is the difference between the Revenue generated (in %) in Canada in 2008 and the Revenue generated (in %) in Suriname in 2010?
Offer a terse response. 6.25. What is the difference between the Revenue generated (in %) in Ethiopia in 2008 and the Revenue generated (in %) in Suriname in 2010?
Ensure brevity in your answer.  0.32. What is the difference between the Revenue generated (in %) of Middle East & North Africa (all income levels) in 2009 and the Revenue generated (in %) of Canada in 2010?
Provide a succinct answer. -5.8. What is the difference between the Revenue generated (in %) of Middle East & North Africa (all income levels) in 2009 and the Revenue generated (in %) of Ethiopia in 2010?
Your answer should be very brief. 1.27. What is the difference between the Revenue generated (in %) in Middle East & North Africa (all income levels) in 2009 and the Revenue generated (in %) in Suriname in 2010?
Provide a succinct answer. -0.09. What is the difference between the Revenue generated (in %) of Canada in 2009 and the Revenue generated (in %) of Ethiopia in 2010?
Keep it short and to the point. 6.92. What is the difference between the Revenue generated (in %) in Canada in 2009 and the Revenue generated (in %) in Suriname in 2010?
Keep it short and to the point. 5.55. What is the difference between the Revenue generated (in %) of Ethiopia in 2009 and the Revenue generated (in %) of Suriname in 2010?
Provide a short and direct response. -1.08. What is the average Revenue generated (in %) in Middle East & North Africa (all income levels) per year?
Make the answer very short. 6. What is the average Revenue generated (in %) in Canada per year?
Your response must be concise. 11.48. What is the average Revenue generated (in %) of Ethiopia per year?
Offer a terse response. 8.01. What is the average Revenue generated (in %) of Suriname per year?
Provide a short and direct response. 5.22. In the year 2003, what is the difference between the Revenue generated (in %) in Middle East & North Africa (all income levels) and Revenue generated (in %) in Canada?
Provide a succinct answer. -6.31. In the year 2003, what is the difference between the Revenue generated (in %) of Middle East & North Africa (all income levels) and Revenue generated (in %) of Ethiopia?
Ensure brevity in your answer.  -0.41. In the year 2003, what is the difference between the Revenue generated (in %) in Middle East & North Africa (all income levels) and Revenue generated (in %) in Suriname?
Offer a very short reply. 1.18. In the year 2003, what is the difference between the Revenue generated (in %) of Canada and Revenue generated (in %) of Ethiopia?
Your answer should be compact. 5.9. In the year 2003, what is the difference between the Revenue generated (in %) of Canada and Revenue generated (in %) of Suriname?
Provide a succinct answer. 7.49. In the year 2003, what is the difference between the Revenue generated (in %) in Ethiopia and Revenue generated (in %) in Suriname?
Ensure brevity in your answer.  1.58. In the year 2004, what is the difference between the Revenue generated (in %) in Middle East & North Africa (all income levels) and Revenue generated (in %) in Canada?
Your answer should be very brief. -5.48. In the year 2004, what is the difference between the Revenue generated (in %) in Middle East & North Africa (all income levels) and Revenue generated (in %) in Ethiopia?
Provide a succinct answer. 1.01. In the year 2004, what is the difference between the Revenue generated (in %) in Middle East & North Africa (all income levels) and Revenue generated (in %) in Suriname?
Your answer should be compact. 1.71. In the year 2004, what is the difference between the Revenue generated (in %) of Canada and Revenue generated (in %) of Ethiopia?
Give a very brief answer. 6.48. In the year 2004, what is the difference between the Revenue generated (in %) of Canada and Revenue generated (in %) of Suriname?
Keep it short and to the point. 7.18. In the year 2004, what is the difference between the Revenue generated (in %) of Ethiopia and Revenue generated (in %) of Suriname?
Offer a terse response. 0.7. In the year 2005, what is the difference between the Revenue generated (in %) of Middle East & North Africa (all income levels) and Revenue generated (in %) of Canada?
Ensure brevity in your answer.  -4.33. In the year 2005, what is the difference between the Revenue generated (in %) in Middle East & North Africa (all income levels) and Revenue generated (in %) in Ethiopia?
Offer a terse response. 1.29. In the year 2005, what is the difference between the Revenue generated (in %) of Middle East & North Africa (all income levels) and Revenue generated (in %) of Suriname?
Provide a short and direct response. 0.87. In the year 2005, what is the difference between the Revenue generated (in %) of Canada and Revenue generated (in %) of Ethiopia?
Provide a succinct answer. 5.62. In the year 2005, what is the difference between the Revenue generated (in %) in Canada and Revenue generated (in %) in Suriname?
Provide a short and direct response. 5.2. In the year 2005, what is the difference between the Revenue generated (in %) of Ethiopia and Revenue generated (in %) of Suriname?
Ensure brevity in your answer.  -0.42. In the year 2006, what is the difference between the Revenue generated (in %) in Middle East & North Africa (all income levels) and Revenue generated (in %) in Canada?
Provide a short and direct response. -4.77. In the year 2006, what is the difference between the Revenue generated (in %) in Middle East & North Africa (all income levels) and Revenue generated (in %) in Ethiopia?
Provide a short and direct response. -11.01. In the year 2006, what is the difference between the Revenue generated (in %) of Middle East & North Africa (all income levels) and Revenue generated (in %) of Suriname?
Provide a short and direct response. 0.55. In the year 2006, what is the difference between the Revenue generated (in %) of Canada and Revenue generated (in %) of Ethiopia?
Provide a short and direct response. -6.24. In the year 2006, what is the difference between the Revenue generated (in %) in Canada and Revenue generated (in %) in Suriname?
Keep it short and to the point. 5.32. In the year 2006, what is the difference between the Revenue generated (in %) of Ethiopia and Revenue generated (in %) of Suriname?
Offer a very short reply. 11.56. In the year 2007, what is the difference between the Revenue generated (in %) of Middle East & North Africa (all income levels) and Revenue generated (in %) of Canada?
Offer a terse response. -6.33. In the year 2007, what is the difference between the Revenue generated (in %) in Middle East & North Africa (all income levels) and Revenue generated (in %) in Ethiopia?
Give a very brief answer. -9.98. In the year 2007, what is the difference between the Revenue generated (in %) of Middle East & North Africa (all income levels) and Revenue generated (in %) of Suriname?
Provide a succinct answer. 0.3. In the year 2007, what is the difference between the Revenue generated (in %) of Canada and Revenue generated (in %) of Ethiopia?
Give a very brief answer. -3.65. In the year 2007, what is the difference between the Revenue generated (in %) in Canada and Revenue generated (in %) in Suriname?
Provide a succinct answer. 6.63. In the year 2007, what is the difference between the Revenue generated (in %) of Ethiopia and Revenue generated (in %) of Suriname?
Offer a very short reply. 10.28. In the year 2008, what is the difference between the Revenue generated (in %) in Middle East & North Africa (all income levels) and Revenue generated (in %) in Canada?
Offer a very short reply. -6.52. In the year 2008, what is the difference between the Revenue generated (in %) in Middle East & North Africa (all income levels) and Revenue generated (in %) in Ethiopia?
Offer a very short reply. -0.59. In the year 2008, what is the difference between the Revenue generated (in %) in Middle East & North Africa (all income levels) and Revenue generated (in %) in Suriname?
Your answer should be compact. 1.08. In the year 2008, what is the difference between the Revenue generated (in %) in Canada and Revenue generated (in %) in Ethiopia?
Give a very brief answer. 5.93. In the year 2008, what is the difference between the Revenue generated (in %) of Canada and Revenue generated (in %) of Suriname?
Your answer should be very brief. 7.6. In the year 2008, what is the difference between the Revenue generated (in %) in Ethiopia and Revenue generated (in %) in Suriname?
Make the answer very short. 1.67. In the year 2009, what is the difference between the Revenue generated (in %) in Middle East & North Africa (all income levels) and Revenue generated (in %) in Canada?
Offer a very short reply. -5.64. In the year 2009, what is the difference between the Revenue generated (in %) of Middle East & North Africa (all income levels) and Revenue generated (in %) of Ethiopia?
Ensure brevity in your answer.  0.99. In the year 2009, what is the difference between the Revenue generated (in %) in Middle East & North Africa (all income levels) and Revenue generated (in %) in Suriname?
Offer a terse response. -0.64. In the year 2009, what is the difference between the Revenue generated (in %) in Canada and Revenue generated (in %) in Ethiopia?
Offer a very short reply. 6.63. In the year 2009, what is the difference between the Revenue generated (in %) of Canada and Revenue generated (in %) of Suriname?
Offer a terse response. 5. In the year 2009, what is the difference between the Revenue generated (in %) of Ethiopia and Revenue generated (in %) of Suriname?
Ensure brevity in your answer.  -1.63. In the year 2010, what is the difference between the Revenue generated (in %) of Middle East & North Africa (all income levels) and Revenue generated (in %) of Canada?
Provide a short and direct response. -4.47. In the year 2010, what is the difference between the Revenue generated (in %) in Middle East & North Africa (all income levels) and Revenue generated (in %) in Ethiopia?
Keep it short and to the point. 2.61. In the year 2010, what is the difference between the Revenue generated (in %) of Middle East & North Africa (all income levels) and Revenue generated (in %) of Suriname?
Offer a very short reply. 1.25. In the year 2010, what is the difference between the Revenue generated (in %) of Canada and Revenue generated (in %) of Ethiopia?
Your answer should be compact. 7.07. In the year 2010, what is the difference between the Revenue generated (in %) of Canada and Revenue generated (in %) of Suriname?
Provide a short and direct response. 5.71. In the year 2010, what is the difference between the Revenue generated (in %) in Ethiopia and Revenue generated (in %) in Suriname?
Provide a succinct answer. -1.36. What is the ratio of the Revenue generated (in %) in Middle East & North Africa (all income levels) in 2003 to that in 2004?
Provide a succinct answer. 1.06. What is the ratio of the Revenue generated (in %) in Canada in 2003 to that in 2004?
Your response must be concise. 1.1. What is the ratio of the Revenue generated (in %) of Ethiopia in 2003 to that in 2004?
Ensure brevity in your answer.  1.27. What is the ratio of the Revenue generated (in %) in Suriname in 2003 to that in 2004?
Offer a very short reply. 1.16. What is the ratio of the Revenue generated (in %) of Middle East & North Africa (all income levels) in 2003 to that in 2005?
Your answer should be very brief. 1.07. What is the ratio of the Revenue generated (in %) in Canada in 2003 to that in 2005?
Give a very brief answer. 1.21. What is the ratio of the Revenue generated (in %) in Ethiopia in 2003 to that in 2005?
Provide a short and direct response. 1.34. What is the ratio of the Revenue generated (in %) in Suriname in 2003 to that in 2005?
Your answer should be very brief. 1.03. What is the ratio of the Revenue generated (in %) in Middle East & North Africa (all income levels) in 2003 to that in 2006?
Keep it short and to the point. 1.23. What is the ratio of the Revenue generated (in %) of Canada in 2003 to that in 2006?
Your answer should be very brief. 1.27. What is the ratio of the Revenue generated (in %) in Ethiopia in 2003 to that in 2006?
Give a very brief answer. 0.49. What is the ratio of the Revenue generated (in %) of Suriname in 2003 to that in 2006?
Make the answer very short. 1.15. What is the ratio of the Revenue generated (in %) in Middle East & North Africa (all income levels) in 2003 to that in 2007?
Your answer should be very brief. 1.9. What is the ratio of the Revenue generated (in %) of Canada in 2003 to that in 2007?
Provide a succinct answer. 1.36. What is the ratio of the Revenue generated (in %) in Ethiopia in 2003 to that in 2007?
Provide a short and direct response. 0.61. What is the ratio of the Revenue generated (in %) of Suriname in 2003 to that in 2007?
Your answer should be very brief. 1.75. What is the ratio of the Revenue generated (in %) of Middle East & North Africa (all income levels) in 2003 to that in 2008?
Your answer should be compact. 2.26. What is the ratio of the Revenue generated (in %) of Canada in 2003 to that in 2008?
Keep it short and to the point. 1.43. What is the ratio of the Revenue generated (in %) in Ethiopia in 2003 to that in 2008?
Offer a very short reply. 2.04. What is the ratio of the Revenue generated (in %) in Suriname in 2003 to that in 2008?
Your response must be concise. 2.74. What is the ratio of the Revenue generated (in %) in Middle East & North Africa (all income levels) in 2003 to that in 2009?
Your answer should be very brief. 2.15. What is the ratio of the Revenue generated (in %) of Canada in 2003 to that in 2009?
Make the answer very short. 1.54. What is the ratio of the Revenue generated (in %) in Ethiopia in 2003 to that in 2009?
Your answer should be very brief. 3.02. What is the ratio of the Revenue generated (in %) of Suriname in 2003 to that in 2009?
Give a very brief answer. 1.58. What is the ratio of the Revenue generated (in %) in Middle East & North Africa (all income levels) in 2003 to that in 2010?
Offer a very short reply. 1.6. What is the ratio of the Revenue generated (in %) of Canada in 2003 to that in 2010?
Your answer should be very brief. 1.51. What is the ratio of the Revenue generated (in %) in Ethiopia in 2003 to that in 2010?
Ensure brevity in your answer.  3.35. What is the ratio of the Revenue generated (in %) of Suriname in 2003 to that in 2010?
Your answer should be compact. 1.8. What is the ratio of the Revenue generated (in %) in Middle East & North Africa (all income levels) in 2004 to that in 2005?
Your response must be concise. 1.01. What is the ratio of the Revenue generated (in %) in Canada in 2004 to that in 2005?
Your answer should be very brief. 1.1. What is the ratio of the Revenue generated (in %) of Ethiopia in 2004 to that in 2005?
Your answer should be very brief. 1.05. What is the ratio of the Revenue generated (in %) of Suriname in 2004 to that in 2005?
Your answer should be very brief. 0.89. What is the ratio of the Revenue generated (in %) of Middle East & North Africa (all income levels) in 2004 to that in 2006?
Ensure brevity in your answer.  1.16. What is the ratio of the Revenue generated (in %) in Canada in 2004 to that in 2006?
Your answer should be very brief. 1.16. What is the ratio of the Revenue generated (in %) in Ethiopia in 2004 to that in 2006?
Your answer should be compact. 0.39. What is the ratio of the Revenue generated (in %) in Suriname in 2004 to that in 2006?
Ensure brevity in your answer.  0.99. What is the ratio of the Revenue generated (in %) in Middle East & North Africa (all income levels) in 2004 to that in 2007?
Your answer should be very brief. 1.79. What is the ratio of the Revenue generated (in %) of Canada in 2004 to that in 2007?
Provide a short and direct response. 1.24. What is the ratio of the Revenue generated (in %) of Ethiopia in 2004 to that in 2007?
Ensure brevity in your answer.  0.48. What is the ratio of the Revenue generated (in %) in Suriname in 2004 to that in 2007?
Give a very brief answer. 1.5. What is the ratio of the Revenue generated (in %) of Middle East & North Africa (all income levels) in 2004 to that in 2008?
Your answer should be very brief. 2.13. What is the ratio of the Revenue generated (in %) in Canada in 2004 to that in 2008?
Offer a very short reply. 1.31. What is the ratio of the Revenue generated (in %) of Ethiopia in 2004 to that in 2008?
Your answer should be compact. 1.6. What is the ratio of the Revenue generated (in %) in Suriname in 2004 to that in 2008?
Your response must be concise. 2.35. What is the ratio of the Revenue generated (in %) in Middle East & North Africa (all income levels) in 2004 to that in 2009?
Your response must be concise. 2.03. What is the ratio of the Revenue generated (in %) in Canada in 2004 to that in 2009?
Offer a terse response. 1.4. What is the ratio of the Revenue generated (in %) of Ethiopia in 2004 to that in 2009?
Your answer should be compact. 2.37. What is the ratio of the Revenue generated (in %) in Suriname in 2004 to that in 2009?
Your response must be concise. 1.36. What is the ratio of the Revenue generated (in %) in Middle East & North Africa (all income levels) in 2004 to that in 2010?
Ensure brevity in your answer.  1.51. What is the ratio of the Revenue generated (in %) of Canada in 2004 to that in 2010?
Provide a short and direct response. 1.38. What is the ratio of the Revenue generated (in %) in Ethiopia in 2004 to that in 2010?
Ensure brevity in your answer.  2.63. What is the ratio of the Revenue generated (in %) in Suriname in 2004 to that in 2010?
Make the answer very short. 1.55. What is the ratio of the Revenue generated (in %) in Middle East & North Africa (all income levels) in 2005 to that in 2006?
Ensure brevity in your answer.  1.15. What is the ratio of the Revenue generated (in %) of Canada in 2005 to that in 2006?
Offer a very short reply. 1.05. What is the ratio of the Revenue generated (in %) of Ethiopia in 2005 to that in 2006?
Keep it short and to the point. 0.37. What is the ratio of the Revenue generated (in %) in Suriname in 2005 to that in 2006?
Ensure brevity in your answer.  1.11. What is the ratio of the Revenue generated (in %) of Middle East & North Africa (all income levels) in 2005 to that in 2007?
Your answer should be compact. 1.78. What is the ratio of the Revenue generated (in %) of Canada in 2005 to that in 2007?
Provide a succinct answer. 1.13. What is the ratio of the Revenue generated (in %) in Ethiopia in 2005 to that in 2007?
Offer a very short reply. 0.45. What is the ratio of the Revenue generated (in %) of Suriname in 2005 to that in 2007?
Ensure brevity in your answer.  1.69. What is the ratio of the Revenue generated (in %) of Middle East & North Africa (all income levels) in 2005 to that in 2008?
Your answer should be very brief. 2.11. What is the ratio of the Revenue generated (in %) of Canada in 2005 to that in 2008?
Your response must be concise. 1.19. What is the ratio of the Revenue generated (in %) of Ethiopia in 2005 to that in 2008?
Make the answer very short. 1.52. What is the ratio of the Revenue generated (in %) in Suriname in 2005 to that in 2008?
Keep it short and to the point. 2.65. What is the ratio of the Revenue generated (in %) of Middle East & North Africa (all income levels) in 2005 to that in 2009?
Make the answer very short. 2.01. What is the ratio of the Revenue generated (in %) in Canada in 2005 to that in 2009?
Give a very brief answer. 1.27. What is the ratio of the Revenue generated (in %) of Ethiopia in 2005 to that in 2009?
Your response must be concise. 2.25. What is the ratio of the Revenue generated (in %) in Suriname in 2005 to that in 2009?
Ensure brevity in your answer.  1.53. What is the ratio of the Revenue generated (in %) in Middle East & North Africa (all income levels) in 2005 to that in 2010?
Offer a very short reply. 1.5. What is the ratio of the Revenue generated (in %) in Canada in 2005 to that in 2010?
Ensure brevity in your answer.  1.25. What is the ratio of the Revenue generated (in %) of Ethiopia in 2005 to that in 2010?
Make the answer very short. 2.5. What is the ratio of the Revenue generated (in %) in Suriname in 2005 to that in 2010?
Keep it short and to the point. 1.75. What is the ratio of the Revenue generated (in %) in Middle East & North Africa (all income levels) in 2006 to that in 2007?
Make the answer very short. 1.54. What is the ratio of the Revenue generated (in %) in Canada in 2006 to that in 2007?
Provide a short and direct response. 1.08. What is the ratio of the Revenue generated (in %) in Ethiopia in 2006 to that in 2007?
Make the answer very short. 1.24. What is the ratio of the Revenue generated (in %) in Suriname in 2006 to that in 2007?
Provide a succinct answer. 1.52. What is the ratio of the Revenue generated (in %) of Middle East & North Africa (all income levels) in 2006 to that in 2008?
Offer a very short reply. 1.83. What is the ratio of the Revenue generated (in %) of Canada in 2006 to that in 2008?
Your answer should be very brief. 1.13. What is the ratio of the Revenue generated (in %) of Ethiopia in 2006 to that in 2008?
Make the answer very short. 4.15. What is the ratio of the Revenue generated (in %) of Suriname in 2006 to that in 2008?
Keep it short and to the point. 2.38. What is the ratio of the Revenue generated (in %) of Middle East & North Africa (all income levels) in 2006 to that in 2009?
Your answer should be compact. 1.75. What is the ratio of the Revenue generated (in %) of Canada in 2006 to that in 2009?
Offer a very short reply. 1.21. What is the ratio of the Revenue generated (in %) of Ethiopia in 2006 to that in 2009?
Give a very brief answer. 6.14. What is the ratio of the Revenue generated (in %) of Suriname in 2006 to that in 2009?
Give a very brief answer. 1.38. What is the ratio of the Revenue generated (in %) of Middle East & North Africa (all income levels) in 2006 to that in 2010?
Offer a terse response. 1.3. What is the ratio of the Revenue generated (in %) of Canada in 2006 to that in 2010?
Ensure brevity in your answer.  1.19. What is the ratio of the Revenue generated (in %) in Ethiopia in 2006 to that in 2010?
Keep it short and to the point. 6.81. What is the ratio of the Revenue generated (in %) of Suriname in 2006 to that in 2010?
Provide a succinct answer. 1.57. What is the ratio of the Revenue generated (in %) in Middle East & North Africa (all income levels) in 2007 to that in 2008?
Offer a terse response. 1.19. What is the ratio of the Revenue generated (in %) of Canada in 2007 to that in 2008?
Your answer should be compact. 1.05. What is the ratio of the Revenue generated (in %) in Ethiopia in 2007 to that in 2008?
Give a very brief answer. 3.35. What is the ratio of the Revenue generated (in %) of Suriname in 2007 to that in 2008?
Your answer should be compact. 1.57. What is the ratio of the Revenue generated (in %) in Middle East & North Africa (all income levels) in 2007 to that in 2009?
Make the answer very short. 1.13. What is the ratio of the Revenue generated (in %) of Canada in 2007 to that in 2009?
Give a very brief answer. 1.13. What is the ratio of the Revenue generated (in %) of Ethiopia in 2007 to that in 2009?
Offer a very short reply. 4.96. What is the ratio of the Revenue generated (in %) of Suriname in 2007 to that in 2009?
Give a very brief answer. 0.91. What is the ratio of the Revenue generated (in %) in Middle East & North Africa (all income levels) in 2007 to that in 2010?
Give a very brief answer. 0.84. What is the ratio of the Revenue generated (in %) in Canada in 2007 to that in 2010?
Keep it short and to the point. 1.11. What is the ratio of the Revenue generated (in %) of Ethiopia in 2007 to that in 2010?
Your answer should be very brief. 5.51. What is the ratio of the Revenue generated (in %) of Suriname in 2007 to that in 2010?
Your answer should be compact. 1.03. What is the ratio of the Revenue generated (in %) of Middle East & North Africa (all income levels) in 2008 to that in 2009?
Provide a short and direct response. 0.95. What is the ratio of the Revenue generated (in %) in Canada in 2008 to that in 2009?
Make the answer very short. 1.07. What is the ratio of the Revenue generated (in %) in Ethiopia in 2008 to that in 2009?
Give a very brief answer. 1.48. What is the ratio of the Revenue generated (in %) of Suriname in 2008 to that in 2009?
Offer a terse response. 0.58. What is the ratio of the Revenue generated (in %) of Middle East & North Africa (all income levels) in 2008 to that in 2010?
Your answer should be very brief. 0.71. What is the ratio of the Revenue generated (in %) of Canada in 2008 to that in 2010?
Your answer should be compact. 1.06. What is the ratio of the Revenue generated (in %) of Ethiopia in 2008 to that in 2010?
Give a very brief answer. 1.64. What is the ratio of the Revenue generated (in %) in Suriname in 2008 to that in 2010?
Your response must be concise. 0.66. What is the ratio of the Revenue generated (in %) in Middle East & North Africa (all income levels) in 2009 to that in 2010?
Your response must be concise. 0.74. What is the ratio of the Revenue generated (in %) of Canada in 2009 to that in 2010?
Your response must be concise. 0.98. What is the ratio of the Revenue generated (in %) of Ethiopia in 2009 to that in 2010?
Your answer should be compact. 1.11. What is the ratio of the Revenue generated (in %) in Suriname in 2009 to that in 2010?
Give a very brief answer. 1.14. What is the difference between the highest and the second highest Revenue generated (in %) in Middle East & North Africa (all income levels)?
Offer a terse response. 0.47. What is the difference between the highest and the second highest Revenue generated (in %) in Canada?
Give a very brief answer. 1.3. What is the difference between the highest and the second highest Revenue generated (in %) of Ethiopia?
Your response must be concise. 3.41. What is the difference between the highest and the second highest Revenue generated (in %) of Suriname?
Ensure brevity in your answer.  0.22. What is the difference between the highest and the lowest Revenue generated (in %) in Middle East & North Africa (all income levels)?
Provide a short and direct response. 4.65. What is the difference between the highest and the lowest Revenue generated (in %) of Canada?
Offer a terse response. 5.12. What is the difference between the highest and the lowest Revenue generated (in %) of Ethiopia?
Your answer should be compact. 15.18. What is the difference between the highest and the lowest Revenue generated (in %) of Suriname?
Ensure brevity in your answer.  4.55. 